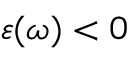<formula> <loc_0><loc_0><loc_500><loc_500>\varepsilon ( \omega ) < 0</formula> 